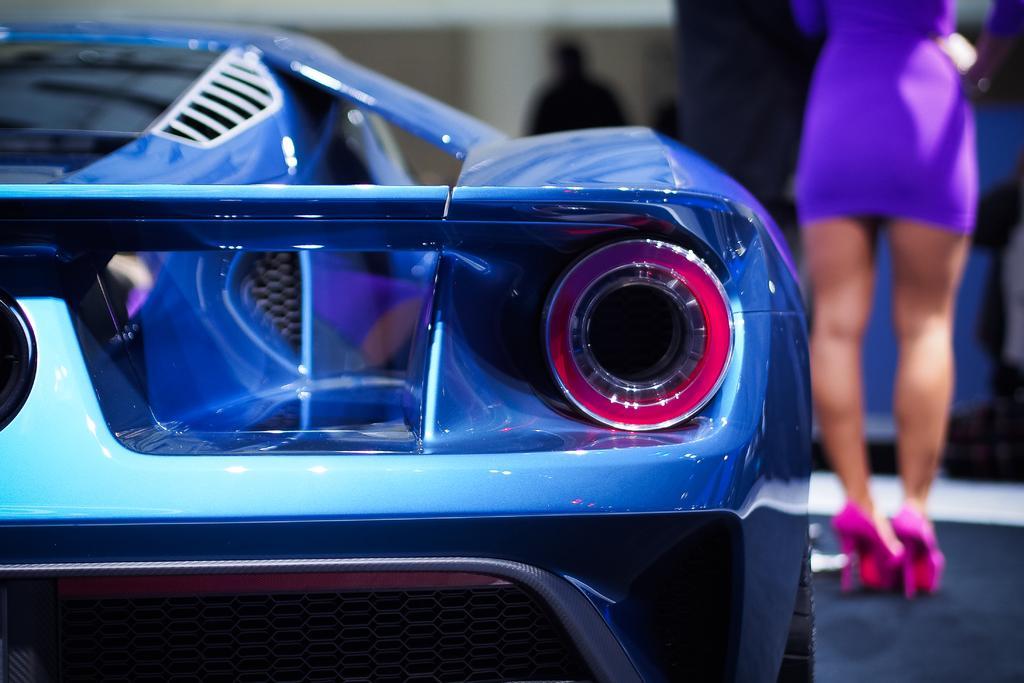Describe this image in one or two sentences. In this picture we can see a car and on the right side of the car a person is standing. Behind the car there is the blurred background. 